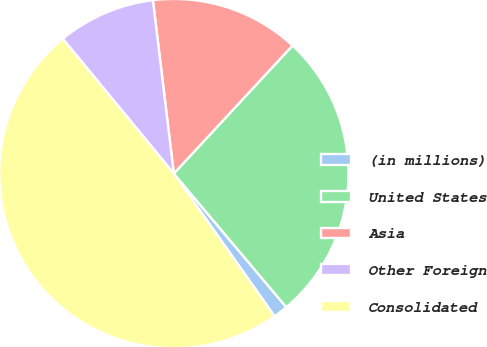Convert chart to OTSL. <chart><loc_0><loc_0><loc_500><loc_500><pie_chart><fcel>(in millions)<fcel>United States<fcel>Asia<fcel>Other Foreign<fcel>Consolidated<nl><fcel>1.35%<fcel>26.97%<fcel>13.81%<fcel>9.06%<fcel>48.82%<nl></chart> 